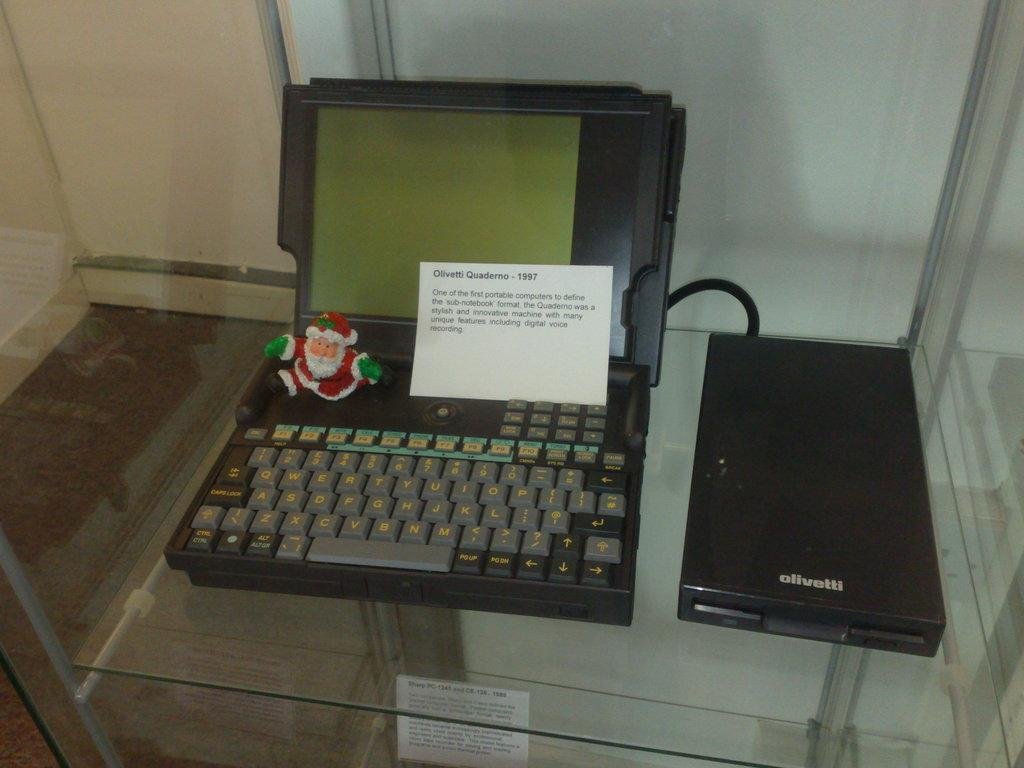<image>
Present a compact description of the photo's key features. the year 1997 is written on the front of a paper 